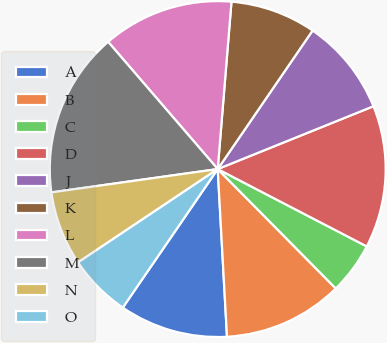<chart> <loc_0><loc_0><loc_500><loc_500><pie_chart><fcel>A<fcel>B<fcel>C<fcel>D<fcel>J<fcel>K<fcel>L<fcel>M<fcel>N<fcel>O<nl><fcel>10.44%<fcel>11.53%<fcel>4.97%<fcel>13.72%<fcel>9.34%<fcel>8.25%<fcel>12.62%<fcel>15.9%<fcel>7.16%<fcel>6.06%<nl></chart> 